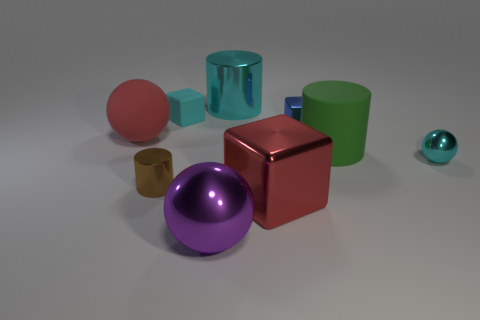Subtract all cyan rubber blocks. How many blocks are left? 2 Subtract 3 cylinders. How many cylinders are left? 0 Subtract all cyan cylinders. How many cylinders are left? 2 Subtract all balls. How many objects are left? 6 Add 8 big green matte cylinders. How many big green matte cylinders are left? 9 Add 8 cyan balls. How many cyan balls exist? 9 Subtract 1 green cylinders. How many objects are left? 8 Subtract all blue cylinders. Subtract all cyan cubes. How many cylinders are left? 3 Subtract all big brown cubes. Subtract all balls. How many objects are left? 6 